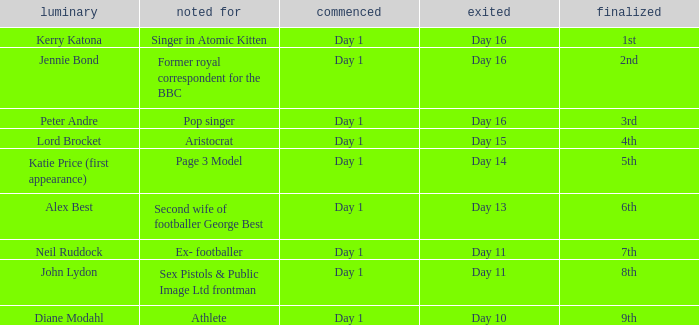Name the entered for famous for page 3 model Day 1. 